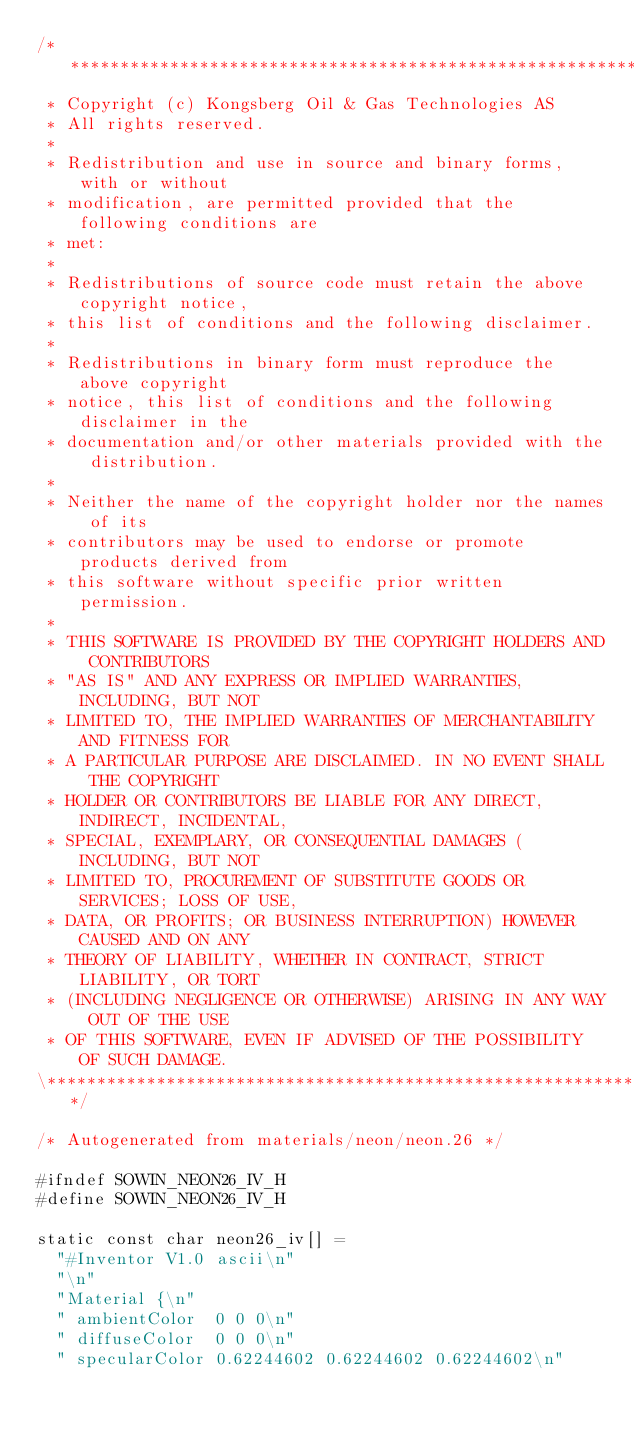<code> <loc_0><loc_0><loc_500><loc_500><_C_>/**************************************************************************\
 * Copyright (c) Kongsberg Oil & Gas Technologies AS
 * All rights reserved.
 * 
 * Redistribution and use in source and binary forms, with or without
 * modification, are permitted provided that the following conditions are
 * met:
 * 
 * Redistributions of source code must retain the above copyright notice,
 * this list of conditions and the following disclaimer.
 * 
 * Redistributions in binary form must reproduce the above copyright
 * notice, this list of conditions and the following disclaimer in the
 * documentation and/or other materials provided with the distribution.
 * 
 * Neither the name of the copyright holder nor the names of its
 * contributors may be used to endorse or promote products derived from
 * this software without specific prior written permission.
 * 
 * THIS SOFTWARE IS PROVIDED BY THE COPYRIGHT HOLDERS AND CONTRIBUTORS
 * "AS IS" AND ANY EXPRESS OR IMPLIED WARRANTIES, INCLUDING, BUT NOT
 * LIMITED TO, THE IMPLIED WARRANTIES OF MERCHANTABILITY AND FITNESS FOR
 * A PARTICULAR PURPOSE ARE DISCLAIMED. IN NO EVENT SHALL THE COPYRIGHT
 * HOLDER OR CONTRIBUTORS BE LIABLE FOR ANY DIRECT, INDIRECT, INCIDENTAL,
 * SPECIAL, EXEMPLARY, OR CONSEQUENTIAL DAMAGES (INCLUDING, BUT NOT
 * LIMITED TO, PROCUREMENT OF SUBSTITUTE GOODS OR SERVICES; LOSS OF USE,
 * DATA, OR PROFITS; OR BUSINESS INTERRUPTION) HOWEVER CAUSED AND ON ANY
 * THEORY OF LIABILITY, WHETHER IN CONTRACT, STRICT LIABILITY, OR TORT
 * (INCLUDING NEGLIGENCE OR OTHERWISE) ARISING IN ANY WAY OUT OF THE USE
 * OF THIS SOFTWARE, EVEN IF ADVISED OF THE POSSIBILITY OF SUCH DAMAGE.
\**************************************************************************/

/* Autogenerated from materials/neon/neon.26 */

#ifndef SOWIN_NEON26_IV_H
#define SOWIN_NEON26_IV_H

static const char neon26_iv[] =
  "#Inventor V1.0 ascii\n"
  "\n"
  "Material {\n"
  "	ambientColor	0 0 0\n"
  "	diffuseColor	0 0 0\n"
  "	specularColor	0.62244602 0.62244602 0.62244602\n"</code> 